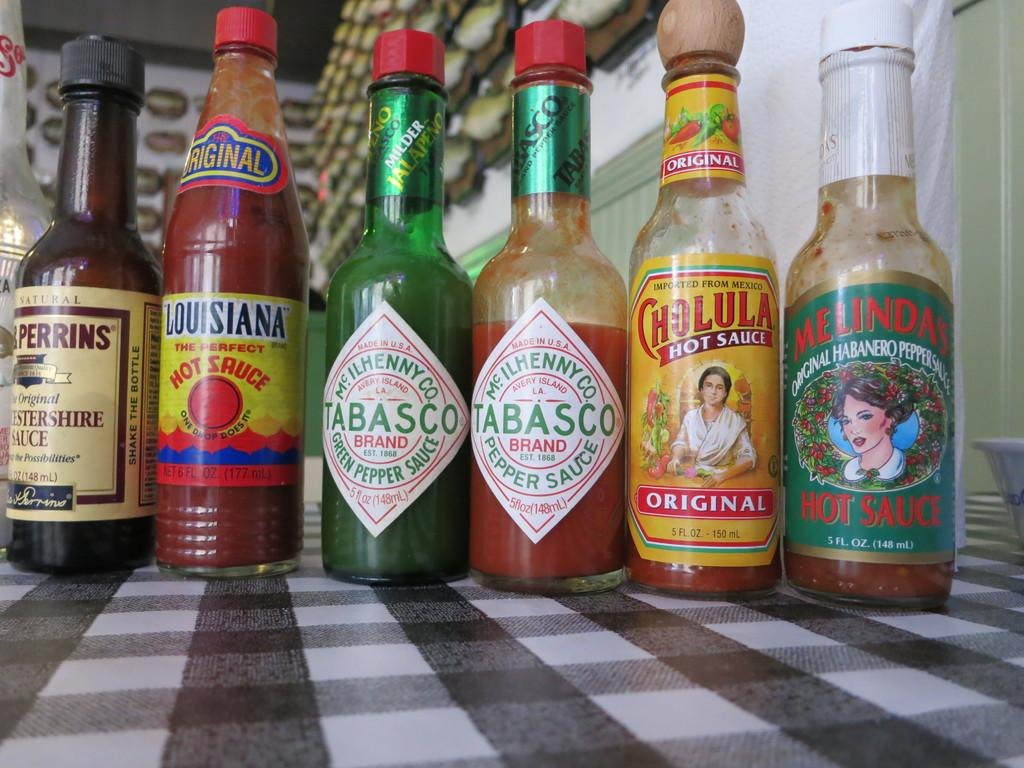Provide a one-sentence caption for the provided image. Six bottles of sauce are on a checkerboard surface, two of which are Tabasco. 